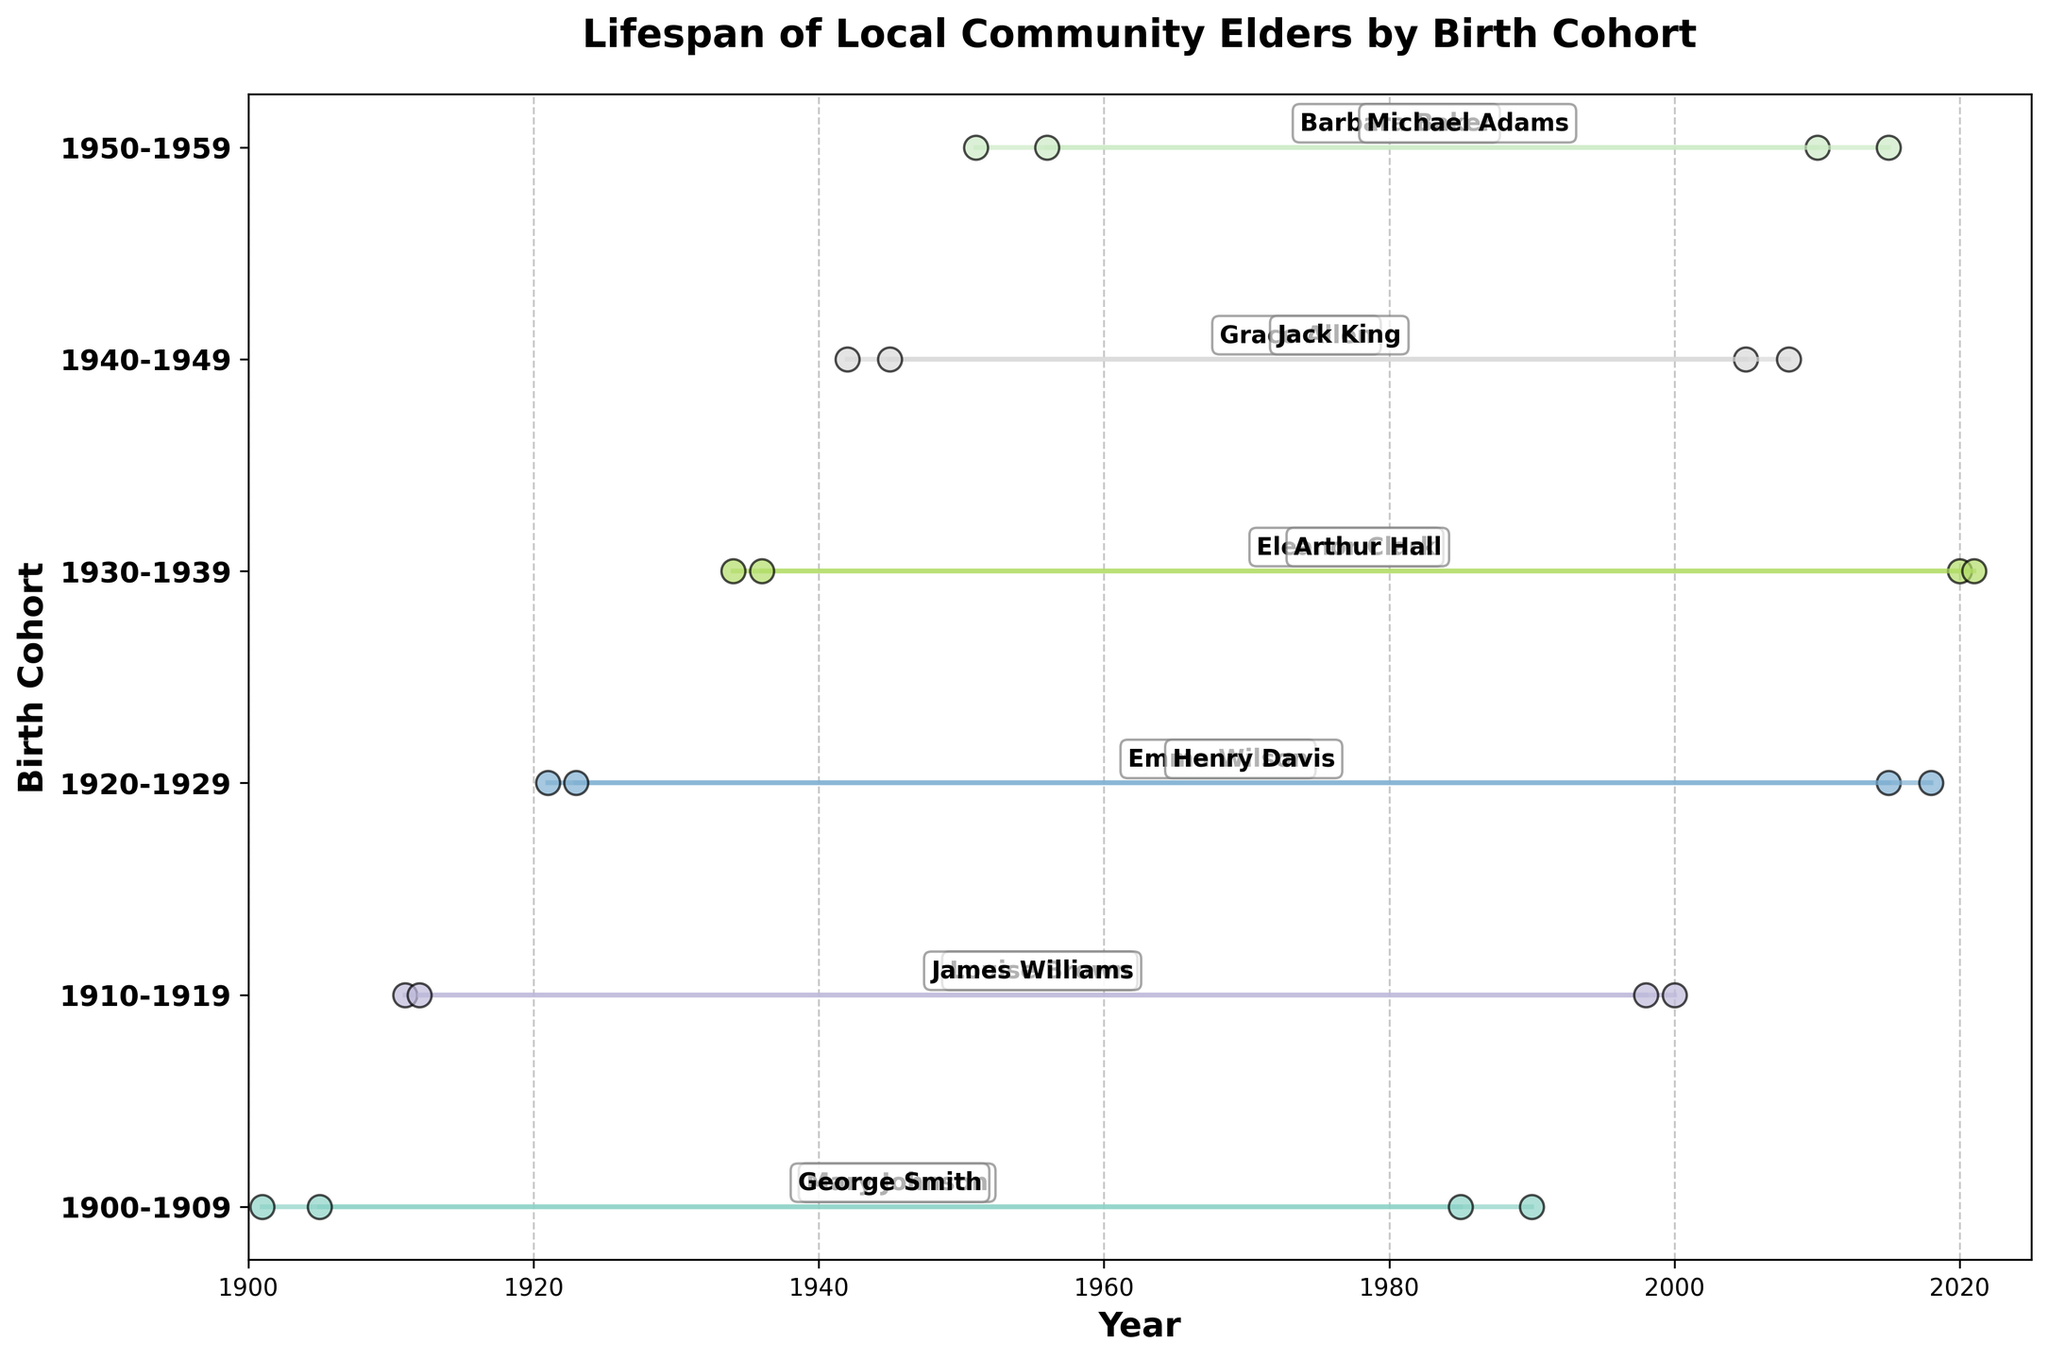how many birth cohorts are represented in the figure? The y-axis labels of the ranged dot plot show the different birth cohorts. If we count these labels, we can determine the number of birth cohorts represented in the figure.
Answer: 6 Which elder has the longest lifespan in the 1910-1919 birth cohort? For the 1910-1919 birth cohort, we look at the ends of the horizontal lines to see which reaches the farthest end; Louise Brown’s line ends at 2000, which is longer than James Williams' line ending at 1998.
Answer: Louise Brown Between the cohorts 1930-1939 and 1940-1949, which had individuals with the longest lives? We compare the longest lives within these cohorts by observing the horizontal lines. In 1930-1939, Eleanor Clark lived until 2020, and Arthur Hall until 2021; in 1940-1949, Grace Allen lived until 2005 and Jack King until 2008. Comparing 2020 and 2021 to 2005 and 2008, we see that the 1930-1939 cohort had the longest lives.
Answer: 1930-1939 What is the average end year for the elders in the 1950-1959 birth cohort? The end years for this cohort are 2010 and 2015. Adding these, we get 2010 + 2015 = 4025, then dividing by 2 (number of elders), the average is 4025/2 = 2012.5
Answer: 2012.5 Which birth cohort has the shortest average lifespan? We calculate the average lifespan for each cohort by finding the difference between each elder's start and end year, then averaging these lifespans within each cohort. The cohort with the smallest average value has the shortest lifespan. Checking: 
- 1900-1909: (1990-1901), (1985-1905) => (89, 80) => avg=84.5
- 1910-1919: (2000-1911), (1998-1912) => (89, 86) => avg=85
- 1920-1929: (2015-1921), (2018-1923) => (94, 95) => avg=94.5
- 1930-1939: (2020-1934), (2021-1936) => (86, 85) => avg=85.5
- 1940-1949: (2005-1942), (2008-1945) => (63, 63) => avg=63
- 1950-1959: (2010-1951), (2015-1956) => (59, 59) => avg=59. 
The shortest is 1950-1959 with average 59 years.
Answer: 1950-1959 Who lived the longest life among all the elders in the plot? We find the elder whose lifespan end year is furthest from their start year across all cohorts. Henry Davis (1923-2018) has a lifespan of 95 years which appears the longest after calculation compared to others.
Answer: Henry Davis What is the difference in the average end year between the 1920-1929 and 1940-1949 birth cohorts? For 1920-1929 births: avg = (2015 + 2018) / 2 = 2016.5; for 1940-1949: avg = (2005 + 2008) / 2 = 2006.5. Difference = 2016.5 - 2006.5 = 10 years
Answer: 10 years 